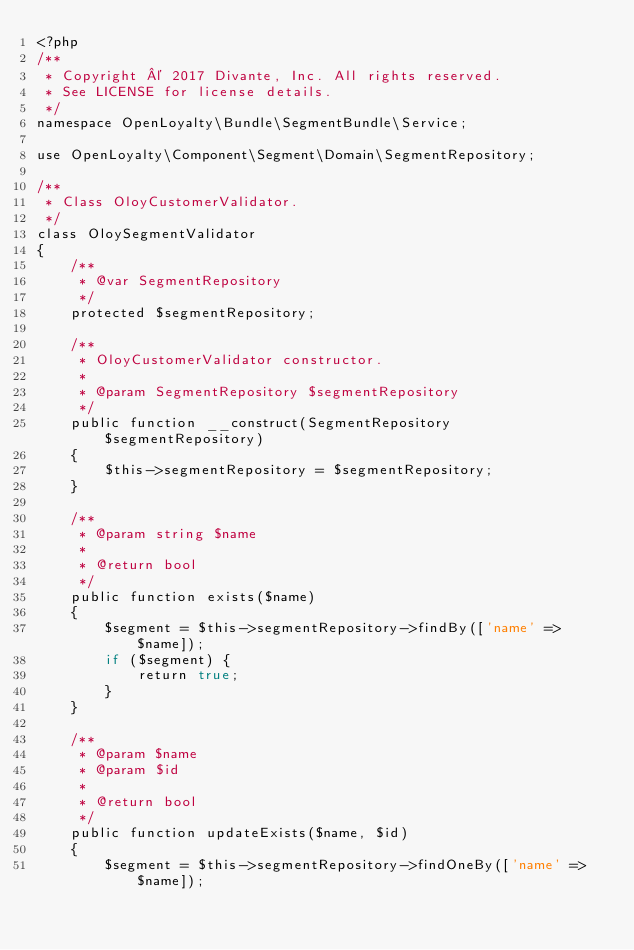<code> <loc_0><loc_0><loc_500><loc_500><_PHP_><?php
/**
 * Copyright © 2017 Divante, Inc. All rights reserved.
 * See LICENSE for license details.
 */
namespace OpenLoyalty\Bundle\SegmentBundle\Service;

use OpenLoyalty\Component\Segment\Domain\SegmentRepository;

/**
 * Class OloyCustomerValidator.
 */
class OloySegmentValidator
{
    /**
     * @var SegmentRepository
     */
    protected $segmentRepository;

    /**
     * OloyCustomerValidator constructor.
     *
     * @param SegmentRepository $segmentRepository
     */
    public function __construct(SegmentRepository $segmentRepository)
    {
        $this->segmentRepository = $segmentRepository;
    }

    /**
     * @param string $name
     *
     * @return bool
     */
    public function exists($name)
    {
        $segment = $this->segmentRepository->findBy(['name' => $name]);
        if ($segment) {
            return true;
        }
    }

    /**
     * @param $name
     * @param $id
     *
     * @return bool
     */
    public function updateExists($name, $id)
    {
        $segment = $this->segmentRepository->findOneBy(['name' => $name]);</code> 